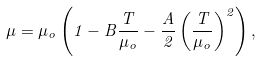Convert formula to latex. <formula><loc_0><loc_0><loc_500><loc_500>\mu = \mu _ { o } \left ( 1 - B \frac { T } { \mu _ { o } } - \frac { A } { 2 } \left ( \frac { T } { \mu _ { o } } \right ) ^ { 2 } \right ) ,</formula> 